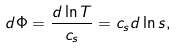<formula> <loc_0><loc_0><loc_500><loc_500>d \Phi = \frac { d \ln T } { c _ { s } } = c _ { s } d \ln s ,</formula> 